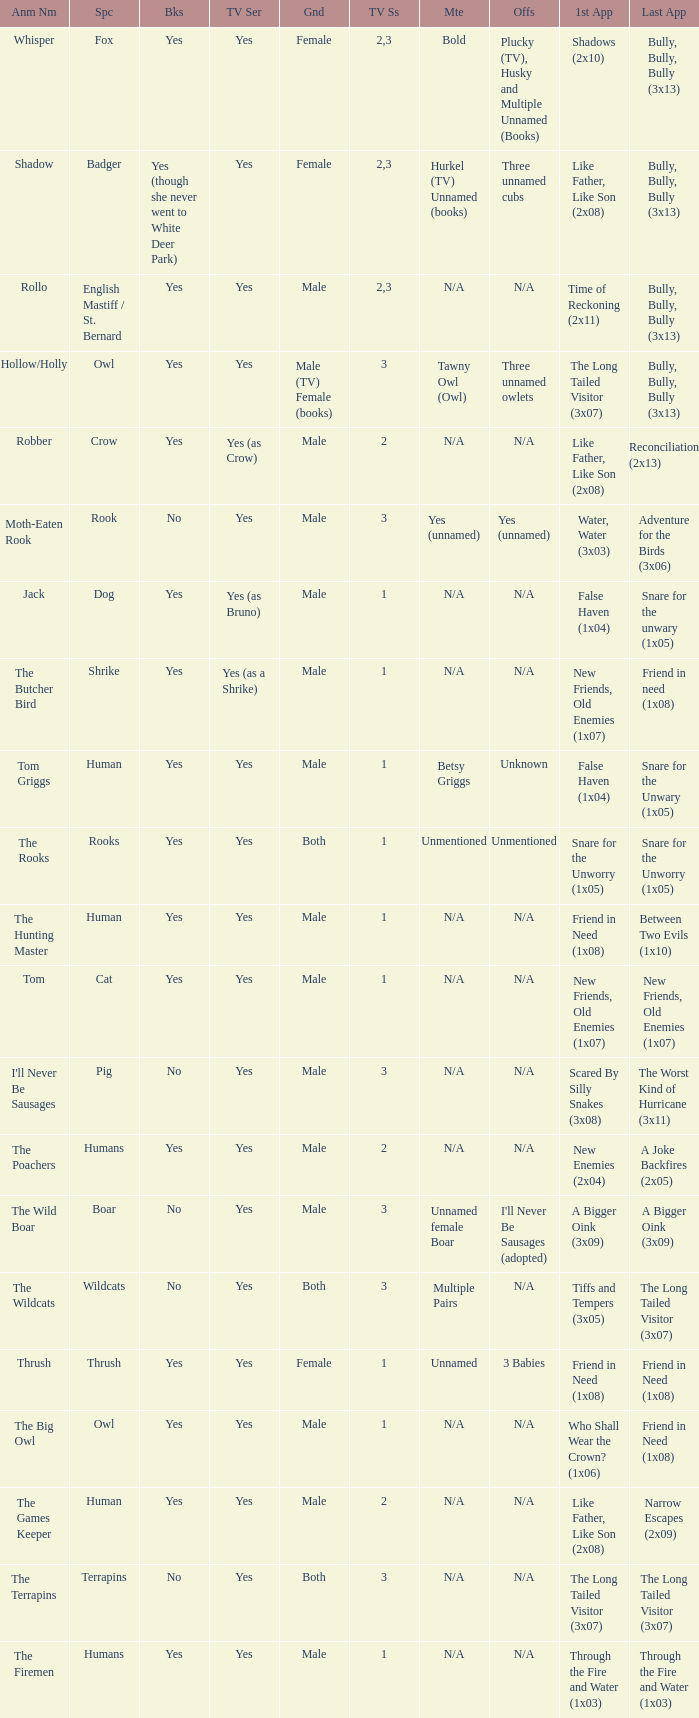What animal was yes for tv series and was a terrapins? The Terrapins. 